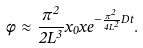<formula> <loc_0><loc_0><loc_500><loc_500>\phi \approx \frac { \pi ^ { 2 } } { 2 L ^ { 3 } } x _ { 0 } x e ^ { - \frac { \pi ^ { 2 } } { 4 L ^ { 2 } } D t } .</formula> 